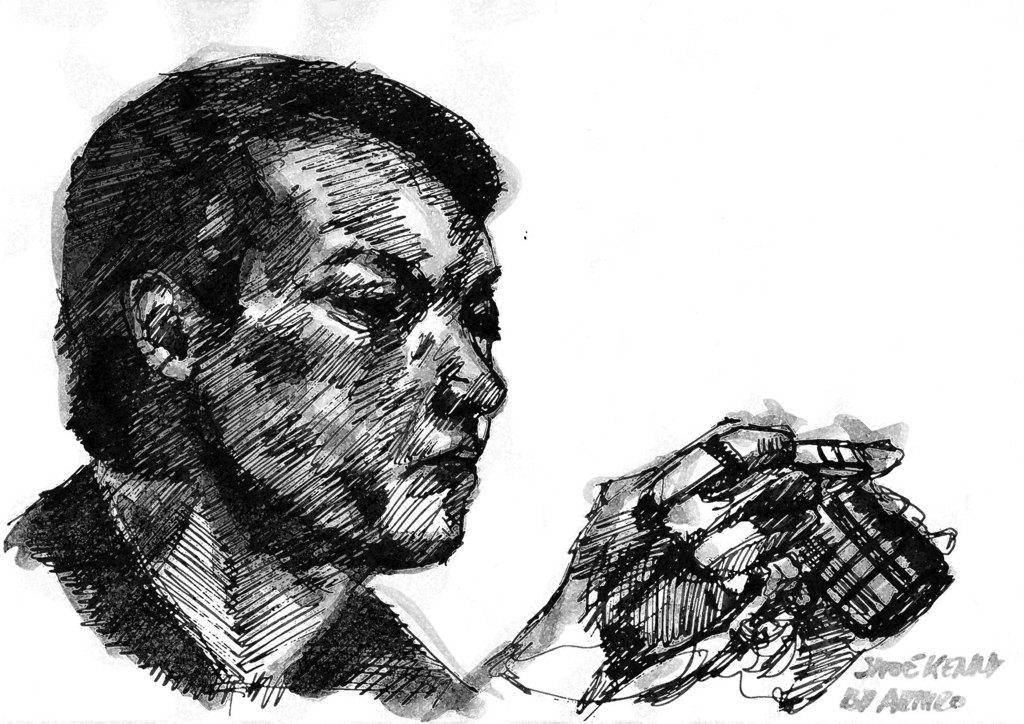What is depicted in the image? There is a drawing of a person in the image. What else can be found in the image besides the drawing? There is text in the image. How much honey is being consumed by the person in the image? There is no honey present in the image, as it only features a drawing of a person and text. 